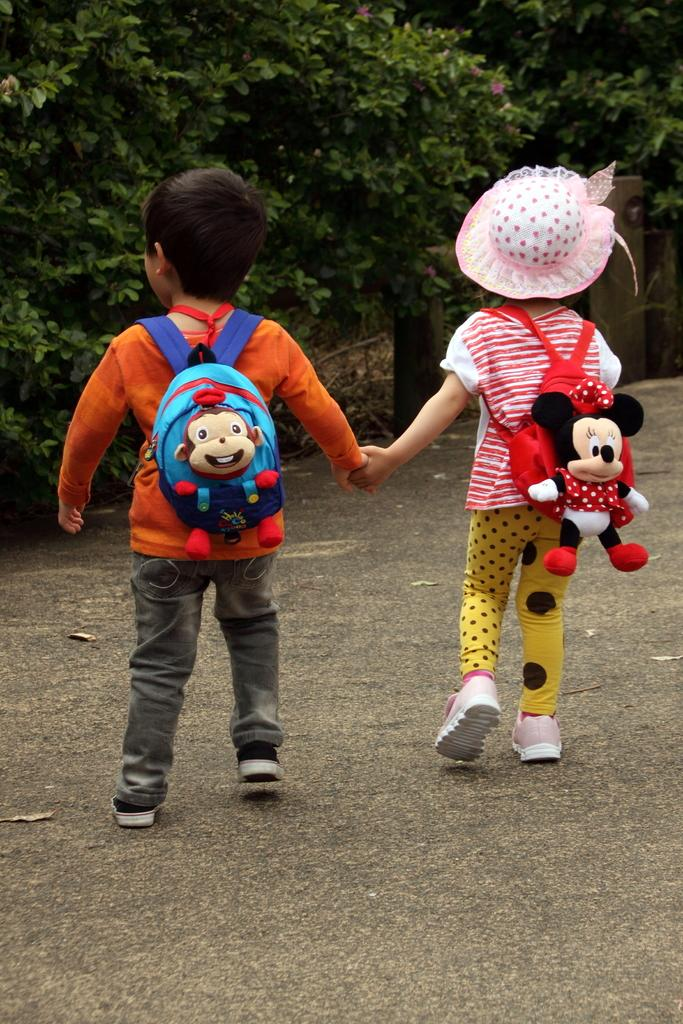How many kids are present in the image? There are two kids in the image. What are the kids wearing on their backs? The kids are wearing bags. What are the kids doing with their hands? The kids are holding hands. Where are the kids walking in the image? The kids are walking on the road. What type of feather can be seen on the stove in the image? There is no stove or feather present in the image. What type of school can be seen in the background of the image? There is no school visible in the image; it only features two kids walking on the road. 